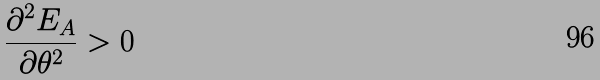Convert formula to latex. <formula><loc_0><loc_0><loc_500><loc_500>\frac { \partial ^ { 2 } E _ { A } } { \partial \theta ^ { 2 } } > 0</formula> 